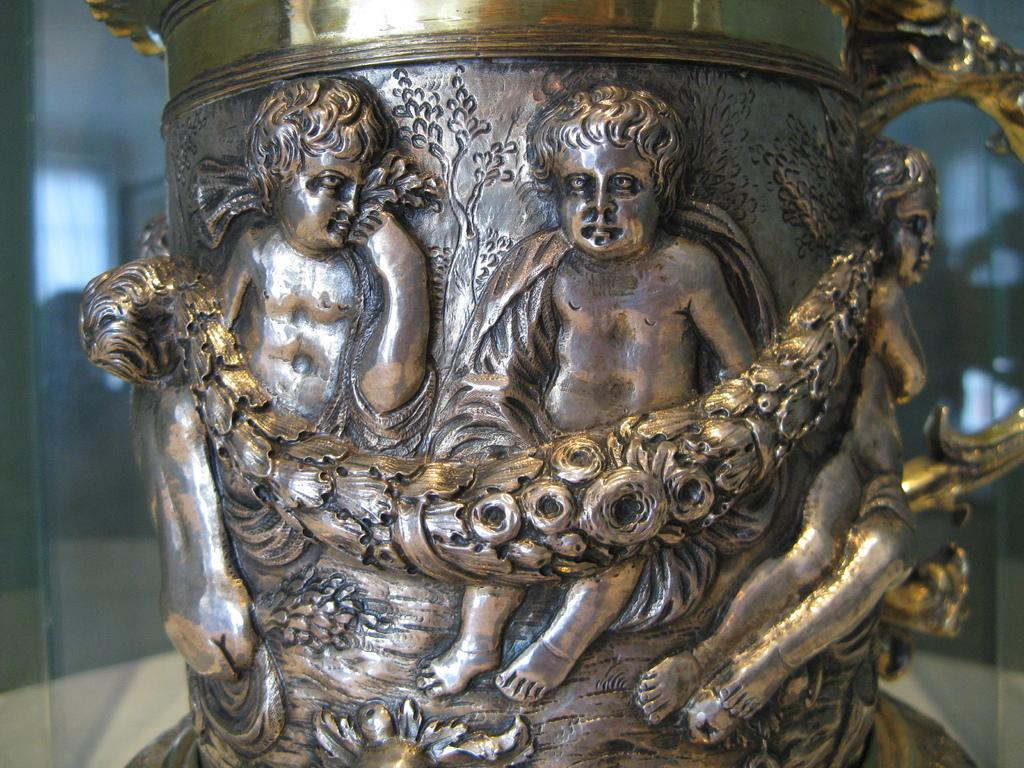What is the main subject of the image? There is a depiction of kids in the center of the image. What type of pancake is being served to the kids in the image? There is no pancake present in the image; it features a depiction of kids. What color is the sweater worn by the kids in the image? The provided facts do not mention any clothing or colors, so we cannot determine the color of a sweater worn by the kids in the image. 